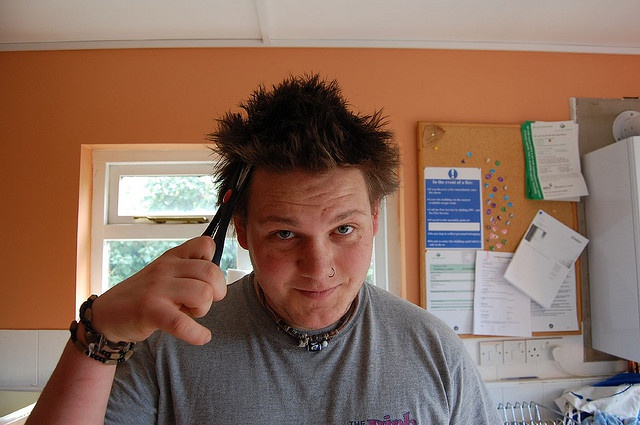Describe the objects in this image and their specific colors. I can see people in gray, black, maroon, and brown tones and scissors in gray, black, maroon, and lightgray tones in this image. 